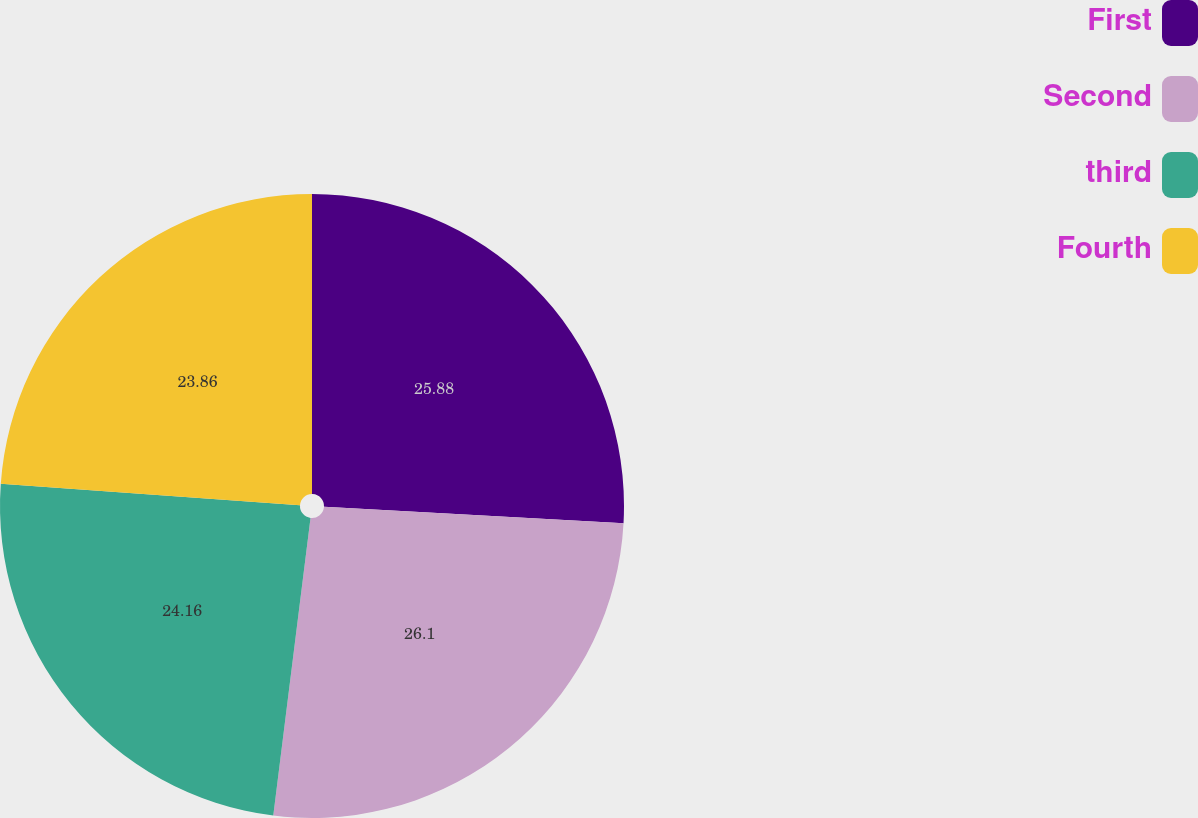Convert chart to OTSL. <chart><loc_0><loc_0><loc_500><loc_500><pie_chart><fcel>First<fcel>Second<fcel>third<fcel>Fourth<nl><fcel>25.88%<fcel>26.1%<fcel>24.16%<fcel>23.86%<nl></chart> 